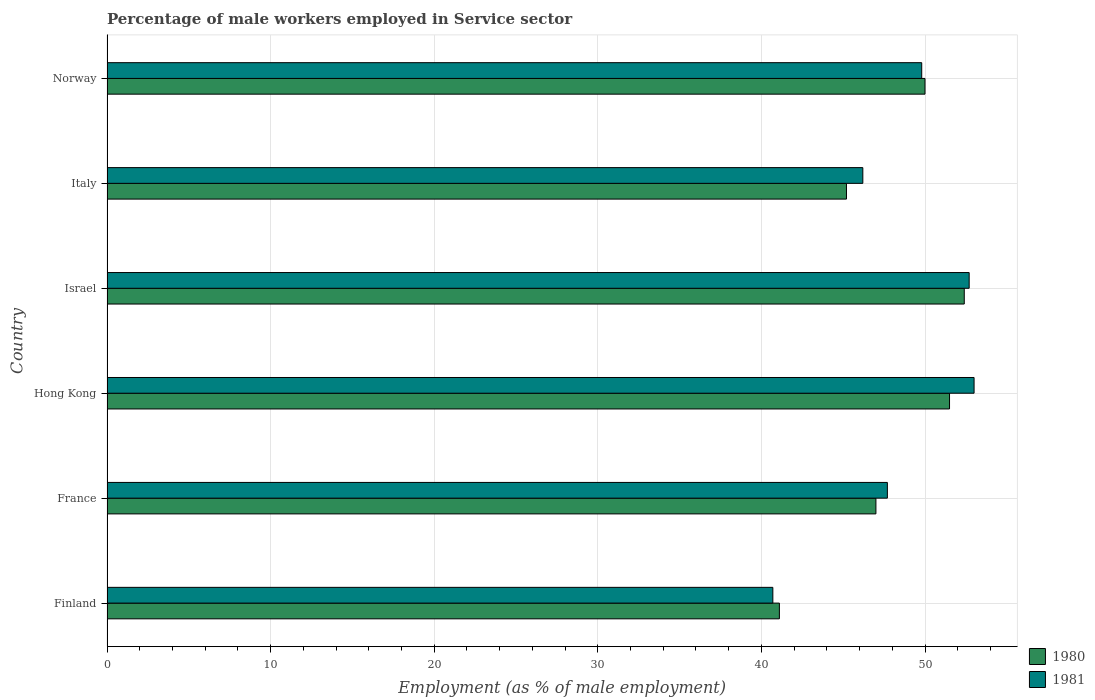How many different coloured bars are there?
Your answer should be compact. 2. How many groups of bars are there?
Provide a short and direct response. 6. How many bars are there on the 3rd tick from the top?
Give a very brief answer. 2. What is the label of the 3rd group of bars from the top?
Your response must be concise. Israel. What is the percentage of male workers employed in Service sector in 1981 in Finland?
Keep it short and to the point. 40.7. Across all countries, what is the maximum percentage of male workers employed in Service sector in 1981?
Give a very brief answer. 53. Across all countries, what is the minimum percentage of male workers employed in Service sector in 1981?
Keep it short and to the point. 40.7. In which country was the percentage of male workers employed in Service sector in 1981 maximum?
Keep it short and to the point. Hong Kong. In which country was the percentage of male workers employed in Service sector in 1980 minimum?
Your answer should be very brief. Finland. What is the total percentage of male workers employed in Service sector in 1981 in the graph?
Your answer should be compact. 290.1. What is the difference between the percentage of male workers employed in Service sector in 1981 in Italy and that in Norway?
Make the answer very short. -3.6. What is the difference between the percentage of male workers employed in Service sector in 1981 in Finland and the percentage of male workers employed in Service sector in 1980 in Norway?
Give a very brief answer. -9.3. What is the average percentage of male workers employed in Service sector in 1981 per country?
Provide a short and direct response. 48.35. What is the difference between the percentage of male workers employed in Service sector in 1980 and percentage of male workers employed in Service sector in 1981 in Norway?
Provide a succinct answer. 0.2. What is the ratio of the percentage of male workers employed in Service sector in 1980 in Israel to that in Italy?
Give a very brief answer. 1.16. What is the difference between the highest and the second highest percentage of male workers employed in Service sector in 1980?
Ensure brevity in your answer.  0.9. What is the difference between the highest and the lowest percentage of male workers employed in Service sector in 1981?
Provide a succinct answer. 12.3. How many bars are there?
Provide a succinct answer. 12. Are all the bars in the graph horizontal?
Give a very brief answer. Yes. How many countries are there in the graph?
Your answer should be compact. 6. What is the difference between two consecutive major ticks on the X-axis?
Your answer should be very brief. 10. What is the title of the graph?
Your answer should be compact. Percentage of male workers employed in Service sector. Does "1987" appear as one of the legend labels in the graph?
Offer a terse response. No. What is the label or title of the X-axis?
Your response must be concise. Employment (as % of male employment). What is the Employment (as % of male employment) of 1980 in Finland?
Give a very brief answer. 41.1. What is the Employment (as % of male employment) in 1981 in Finland?
Your answer should be very brief. 40.7. What is the Employment (as % of male employment) in 1980 in France?
Your answer should be very brief. 47. What is the Employment (as % of male employment) of 1981 in France?
Provide a succinct answer. 47.7. What is the Employment (as % of male employment) of 1980 in Hong Kong?
Ensure brevity in your answer.  51.5. What is the Employment (as % of male employment) of 1981 in Hong Kong?
Your answer should be compact. 53. What is the Employment (as % of male employment) in 1980 in Israel?
Keep it short and to the point. 52.4. What is the Employment (as % of male employment) in 1981 in Israel?
Give a very brief answer. 52.7. What is the Employment (as % of male employment) in 1980 in Italy?
Provide a succinct answer. 45.2. What is the Employment (as % of male employment) of 1981 in Italy?
Keep it short and to the point. 46.2. What is the Employment (as % of male employment) of 1981 in Norway?
Keep it short and to the point. 49.8. Across all countries, what is the maximum Employment (as % of male employment) in 1980?
Give a very brief answer. 52.4. Across all countries, what is the minimum Employment (as % of male employment) of 1980?
Offer a terse response. 41.1. Across all countries, what is the minimum Employment (as % of male employment) in 1981?
Your response must be concise. 40.7. What is the total Employment (as % of male employment) in 1980 in the graph?
Your response must be concise. 287.2. What is the total Employment (as % of male employment) of 1981 in the graph?
Your response must be concise. 290.1. What is the difference between the Employment (as % of male employment) in 1981 in Finland and that in France?
Your answer should be very brief. -7. What is the difference between the Employment (as % of male employment) of 1980 in Finland and that in Israel?
Ensure brevity in your answer.  -11.3. What is the difference between the Employment (as % of male employment) in 1981 in Finland and that in Israel?
Provide a succinct answer. -12. What is the difference between the Employment (as % of male employment) in 1980 in Finland and that in Italy?
Offer a terse response. -4.1. What is the difference between the Employment (as % of male employment) of 1980 in France and that in Hong Kong?
Provide a succinct answer. -4.5. What is the difference between the Employment (as % of male employment) in 1980 in France and that in Italy?
Give a very brief answer. 1.8. What is the difference between the Employment (as % of male employment) of 1981 in Hong Kong and that in Israel?
Ensure brevity in your answer.  0.3. What is the difference between the Employment (as % of male employment) in 1980 in Hong Kong and that in Italy?
Provide a succinct answer. 6.3. What is the difference between the Employment (as % of male employment) of 1981 in Hong Kong and that in Italy?
Your answer should be very brief. 6.8. What is the difference between the Employment (as % of male employment) in 1980 in Hong Kong and that in Norway?
Ensure brevity in your answer.  1.5. What is the difference between the Employment (as % of male employment) in 1980 in Israel and that in Italy?
Give a very brief answer. 7.2. What is the difference between the Employment (as % of male employment) in 1981 in Israel and that in Italy?
Offer a terse response. 6.5. What is the difference between the Employment (as % of male employment) of 1981 in Israel and that in Norway?
Provide a short and direct response. 2.9. What is the difference between the Employment (as % of male employment) in 1981 in Italy and that in Norway?
Keep it short and to the point. -3.6. What is the difference between the Employment (as % of male employment) of 1980 in Finland and the Employment (as % of male employment) of 1981 in Italy?
Make the answer very short. -5.1. What is the difference between the Employment (as % of male employment) in 1980 in Finland and the Employment (as % of male employment) in 1981 in Norway?
Keep it short and to the point. -8.7. What is the difference between the Employment (as % of male employment) in 1980 in France and the Employment (as % of male employment) in 1981 in Hong Kong?
Offer a very short reply. -6. What is the difference between the Employment (as % of male employment) in 1980 in France and the Employment (as % of male employment) in 1981 in Israel?
Offer a very short reply. -5.7. What is the difference between the Employment (as % of male employment) of 1980 in France and the Employment (as % of male employment) of 1981 in Italy?
Offer a very short reply. 0.8. What is the average Employment (as % of male employment) in 1980 per country?
Keep it short and to the point. 47.87. What is the average Employment (as % of male employment) of 1981 per country?
Provide a short and direct response. 48.35. What is the difference between the Employment (as % of male employment) in 1980 and Employment (as % of male employment) in 1981 in France?
Make the answer very short. -0.7. What is the difference between the Employment (as % of male employment) in 1980 and Employment (as % of male employment) in 1981 in Hong Kong?
Offer a very short reply. -1.5. What is the difference between the Employment (as % of male employment) of 1980 and Employment (as % of male employment) of 1981 in Israel?
Your answer should be very brief. -0.3. What is the difference between the Employment (as % of male employment) of 1980 and Employment (as % of male employment) of 1981 in Italy?
Ensure brevity in your answer.  -1. What is the difference between the Employment (as % of male employment) of 1980 and Employment (as % of male employment) of 1981 in Norway?
Offer a terse response. 0.2. What is the ratio of the Employment (as % of male employment) of 1980 in Finland to that in France?
Provide a succinct answer. 0.87. What is the ratio of the Employment (as % of male employment) of 1981 in Finland to that in France?
Your answer should be compact. 0.85. What is the ratio of the Employment (as % of male employment) in 1980 in Finland to that in Hong Kong?
Give a very brief answer. 0.8. What is the ratio of the Employment (as % of male employment) in 1981 in Finland to that in Hong Kong?
Provide a short and direct response. 0.77. What is the ratio of the Employment (as % of male employment) in 1980 in Finland to that in Israel?
Provide a succinct answer. 0.78. What is the ratio of the Employment (as % of male employment) of 1981 in Finland to that in Israel?
Ensure brevity in your answer.  0.77. What is the ratio of the Employment (as % of male employment) in 1980 in Finland to that in Italy?
Provide a short and direct response. 0.91. What is the ratio of the Employment (as % of male employment) of 1981 in Finland to that in Italy?
Keep it short and to the point. 0.88. What is the ratio of the Employment (as % of male employment) of 1980 in Finland to that in Norway?
Provide a succinct answer. 0.82. What is the ratio of the Employment (as % of male employment) in 1981 in Finland to that in Norway?
Keep it short and to the point. 0.82. What is the ratio of the Employment (as % of male employment) of 1980 in France to that in Hong Kong?
Ensure brevity in your answer.  0.91. What is the ratio of the Employment (as % of male employment) in 1980 in France to that in Israel?
Ensure brevity in your answer.  0.9. What is the ratio of the Employment (as % of male employment) of 1981 in France to that in Israel?
Your answer should be compact. 0.91. What is the ratio of the Employment (as % of male employment) of 1980 in France to that in Italy?
Ensure brevity in your answer.  1.04. What is the ratio of the Employment (as % of male employment) of 1981 in France to that in Italy?
Offer a very short reply. 1.03. What is the ratio of the Employment (as % of male employment) of 1981 in France to that in Norway?
Offer a very short reply. 0.96. What is the ratio of the Employment (as % of male employment) in 1980 in Hong Kong to that in Israel?
Ensure brevity in your answer.  0.98. What is the ratio of the Employment (as % of male employment) in 1980 in Hong Kong to that in Italy?
Give a very brief answer. 1.14. What is the ratio of the Employment (as % of male employment) in 1981 in Hong Kong to that in Italy?
Offer a very short reply. 1.15. What is the ratio of the Employment (as % of male employment) of 1981 in Hong Kong to that in Norway?
Your answer should be very brief. 1.06. What is the ratio of the Employment (as % of male employment) in 1980 in Israel to that in Italy?
Keep it short and to the point. 1.16. What is the ratio of the Employment (as % of male employment) of 1981 in Israel to that in Italy?
Ensure brevity in your answer.  1.14. What is the ratio of the Employment (as % of male employment) in 1980 in Israel to that in Norway?
Your answer should be very brief. 1.05. What is the ratio of the Employment (as % of male employment) in 1981 in Israel to that in Norway?
Offer a very short reply. 1.06. What is the ratio of the Employment (as % of male employment) of 1980 in Italy to that in Norway?
Offer a very short reply. 0.9. What is the ratio of the Employment (as % of male employment) in 1981 in Italy to that in Norway?
Your answer should be very brief. 0.93. What is the difference between the highest and the second highest Employment (as % of male employment) of 1980?
Ensure brevity in your answer.  0.9. What is the difference between the highest and the lowest Employment (as % of male employment) in 1980?
Keep it short and to the point. 11.3. 